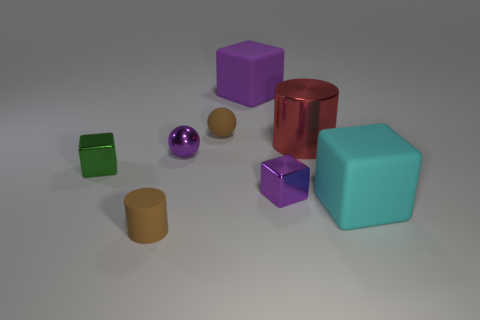Do the cyan thing and the cylinder that is behind the large cyan matte object have the same material?
Your answer should be compact. No. What number of big metallic things are there?
Provide a succinct answer. 1. How big is the cube behind the green metal object?
Offer a very short reply. Large. What number of metallic balls have the same size as the cyan matte object?
Ensure brevity in your answer.  0. What is the object that is both behind the green shiny cube and in front of the big red metallic cylinder made of?
Your response must be concise. Metal. There is a purple object that is the same size as the purple ball; what material is it?
Offer a terse response. Metal. What size is the brown rubber object that is behind the cylinder that is on the left side of the rubber cube left of the red thing?
Your answer should be very brief. Small. The cyan cube that is the same material as the small brown cylinder is what size?
Offer a very short reply. Large. Is the size of the red cylinder the same as the cube to the left of the big purple matte cube?
Offer a very short reply. No. The tiny matte thing that is behind the small rubber cylinder has what shape?
Provide a short and direct response. Sphere. 